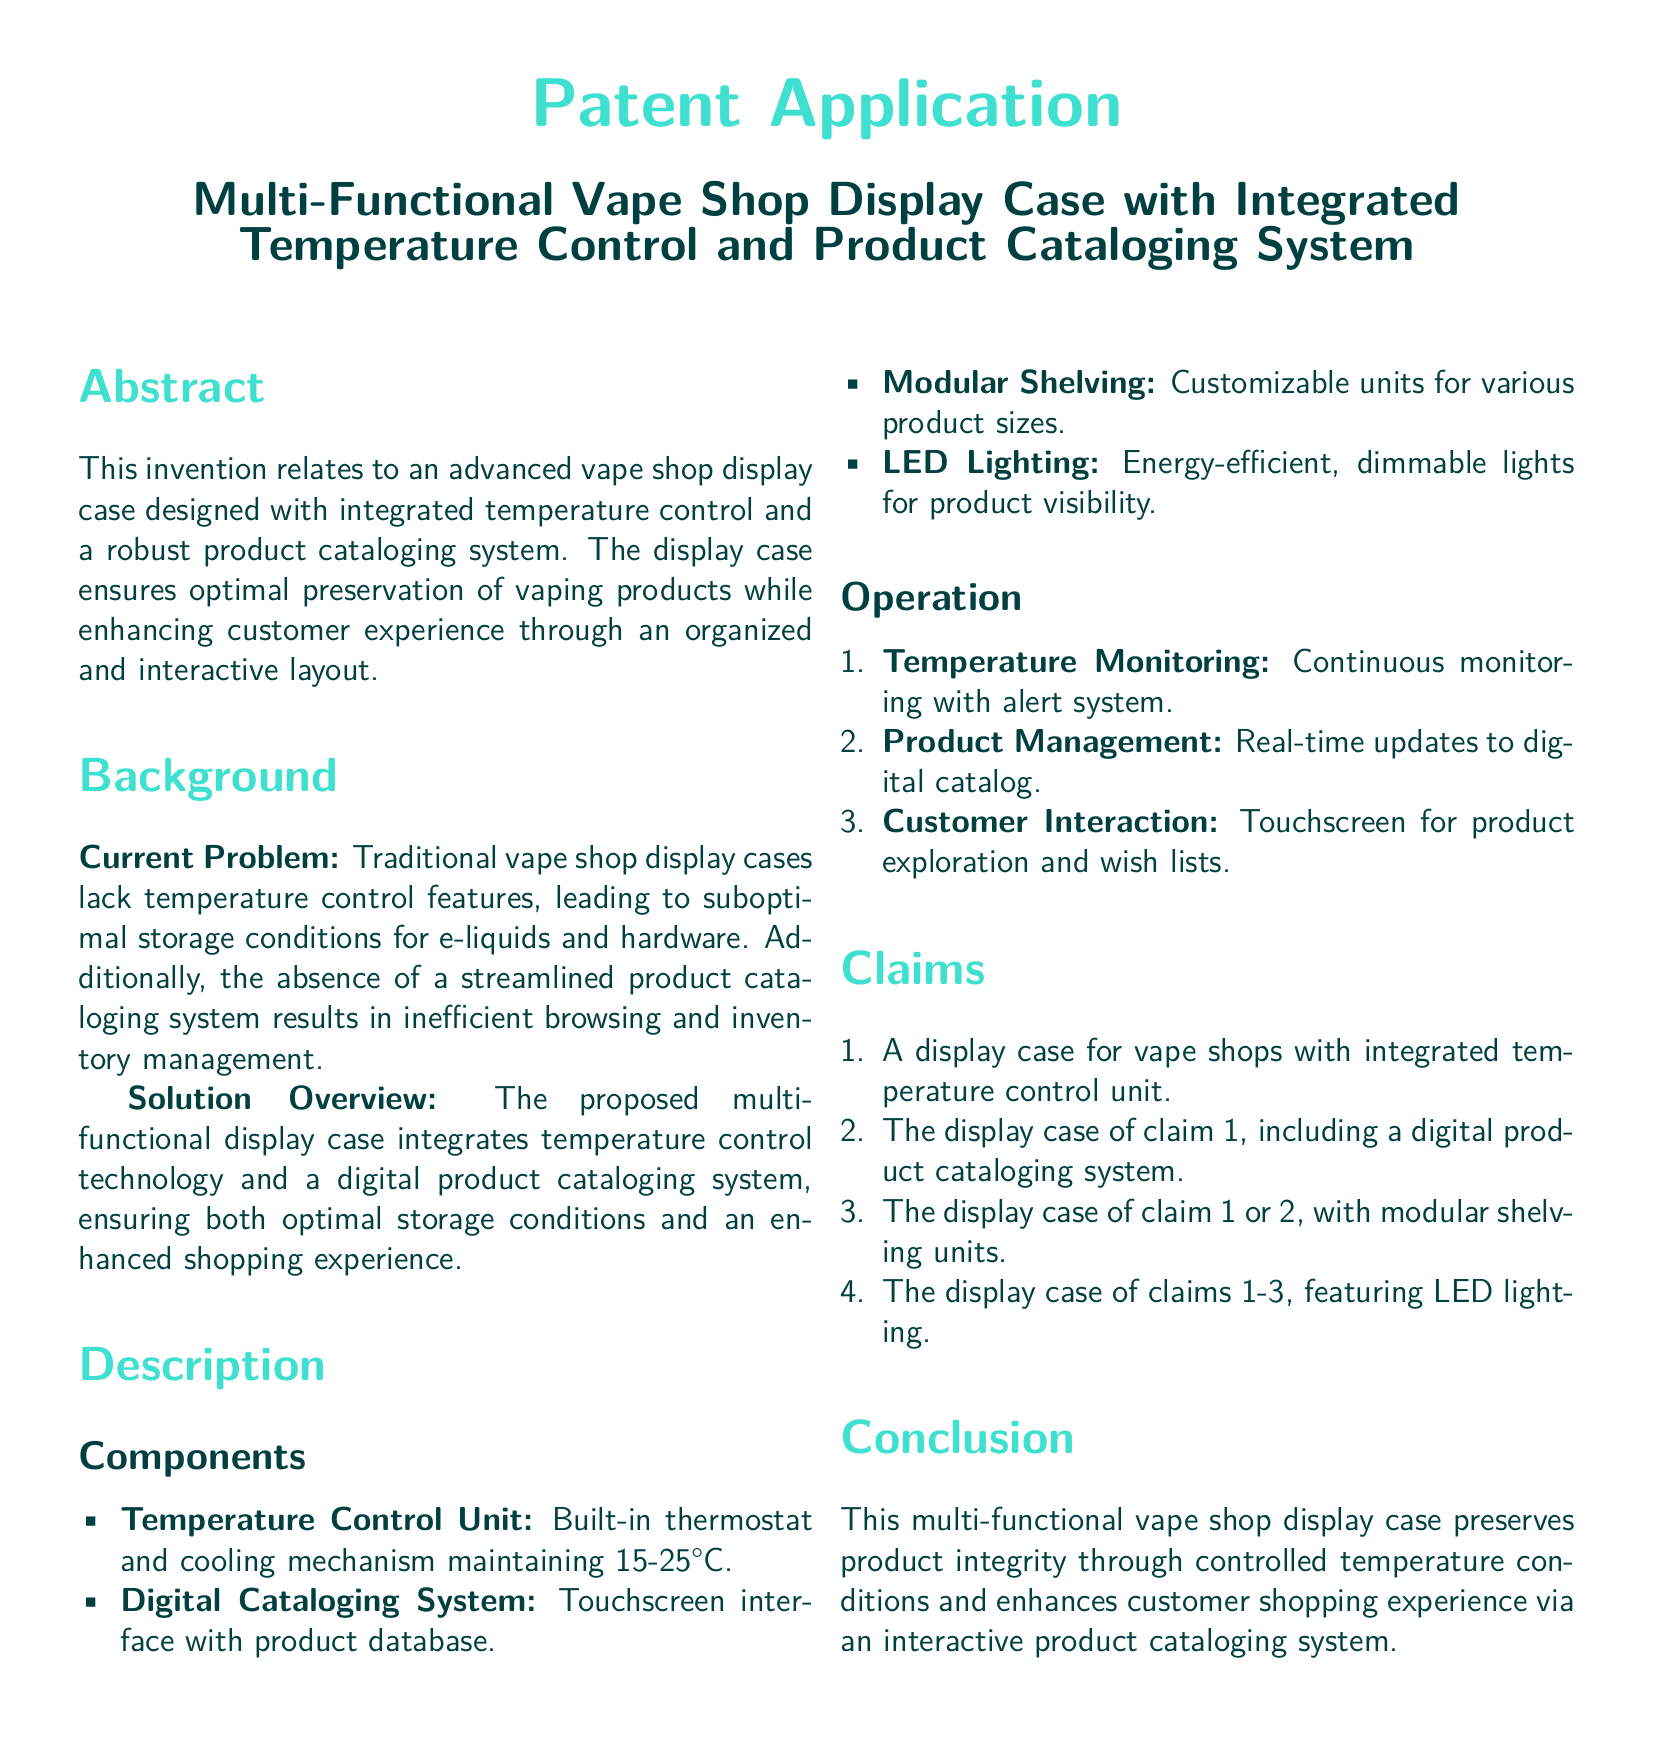What is the main function of the display case? The main function is to ensure optimal preservation of vaping products and enhance customer experience.
Answer: Optimal preservation and enhanced customer experience What temperature range does the temperature control unit maintain? The temperature control unit maintains a temperature range of 15-25°C.
Answer: 15-25°C What technology does the digital cataloging system use? The digital cataloging system features a touchscreen interface with a product database.
Answer: Touchscreen interface with product database How many components are listed in the description section? The description section lists four components of the display case.
Answer: Four What alert feature is included in the temperature monitoring system? The temperature monitoring system includes an alert system for continuous monitoring.
Answer: Alert system What type of lighting is used in the display case? The display case uses energy-efficient, dimmable LED lighting.
Answer: LED lighting What is included in the first claim of the patent? The first claim includes a display case for vape shops with integrated temperature control unit.
Answer: Integrated temperature control unit How does the product management system operate? The product management system operates with real-time updates to the digital catalog.
Answer: Real-time updates What is the purpose of the modular shelving? The purpose of modular shelving is to provide customizable units for various product sizes.
Answer: Customizable units for various product sizes 